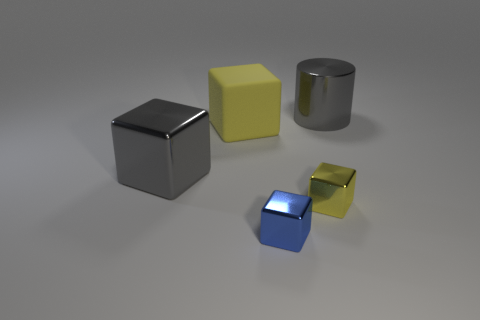There is a blue cube that is the same material as the tiny yellow cube; what size is it?
Keep it short and to the point. Small. Do the blue shiny object in front of the cylinder and the gray shiny cylinder right of the small blue shiny thing have the same size?
Provide a succinct answer. No. What number of things are yellow cubes or large cylinders?
Your answer should be very brief. 3. What shape is the blue thing?
Your answer should be very brief. Cube. The yellow metal object that is the same shape as the large rubber object is what size?
Your answer should be compact. Small. Are there any other things that are made of the same material as the small yellow block?
Keep it short and to the point. Yes. There is a object that is on the right side of the small metal block behind the small blue thing; what is its size?
Ensure brevity in your answer.  Large. Is the number of gray metal cylinders that are in front of the large matte object the same as the number of small purple matte things?
Offer a very short reply. Yes. What number of other things are the same color as the cylinder?
Your response must be concise. 1. Are there fewer yellow matte blocks on the right side of the small blue metallic block than tiny gray balls?
Provide a short and direct response. No. 